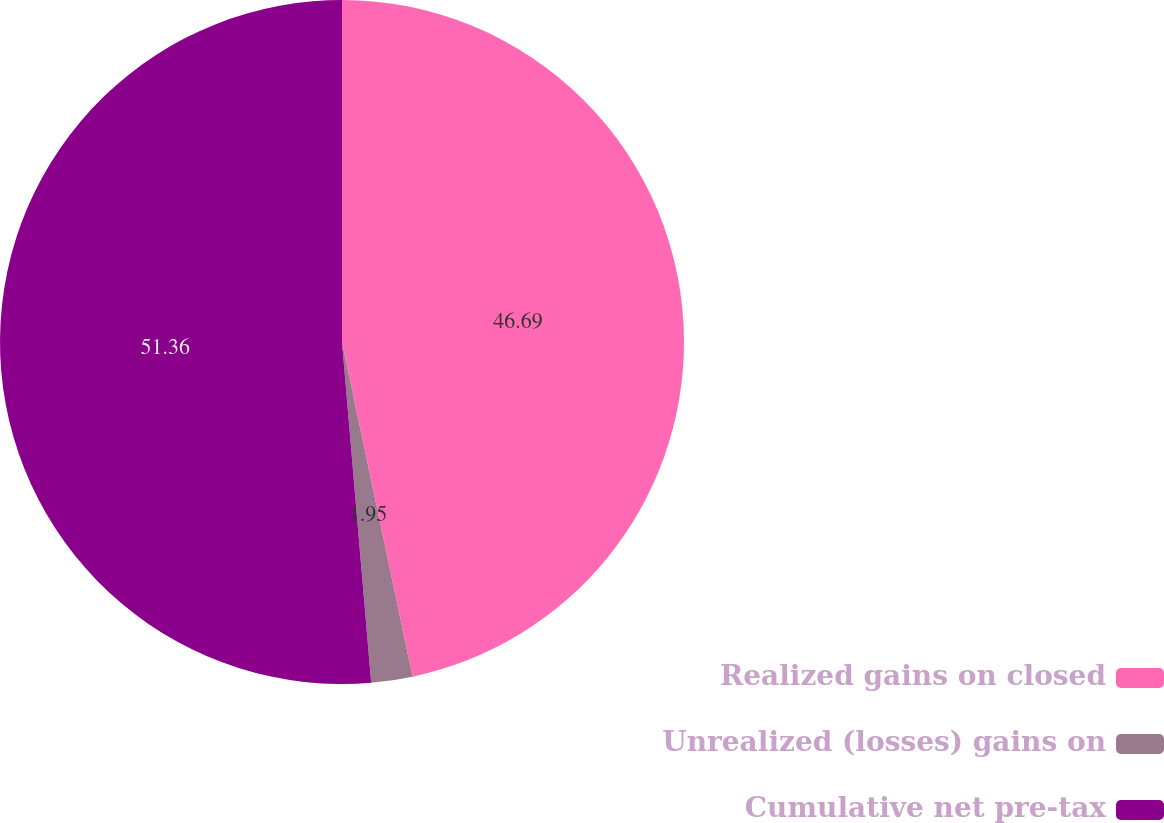Convert chart. <chart><loc_0><loc_0><loc_500><loc_500><pie_chart><fcel>Realized gains on closed<fcel>Unrealized (losses) gains on<fcel>Cumulative net pre-tax<nl><fcel>46.69%<fcel>1.95%<fcel>51.36%<nl></chart> 